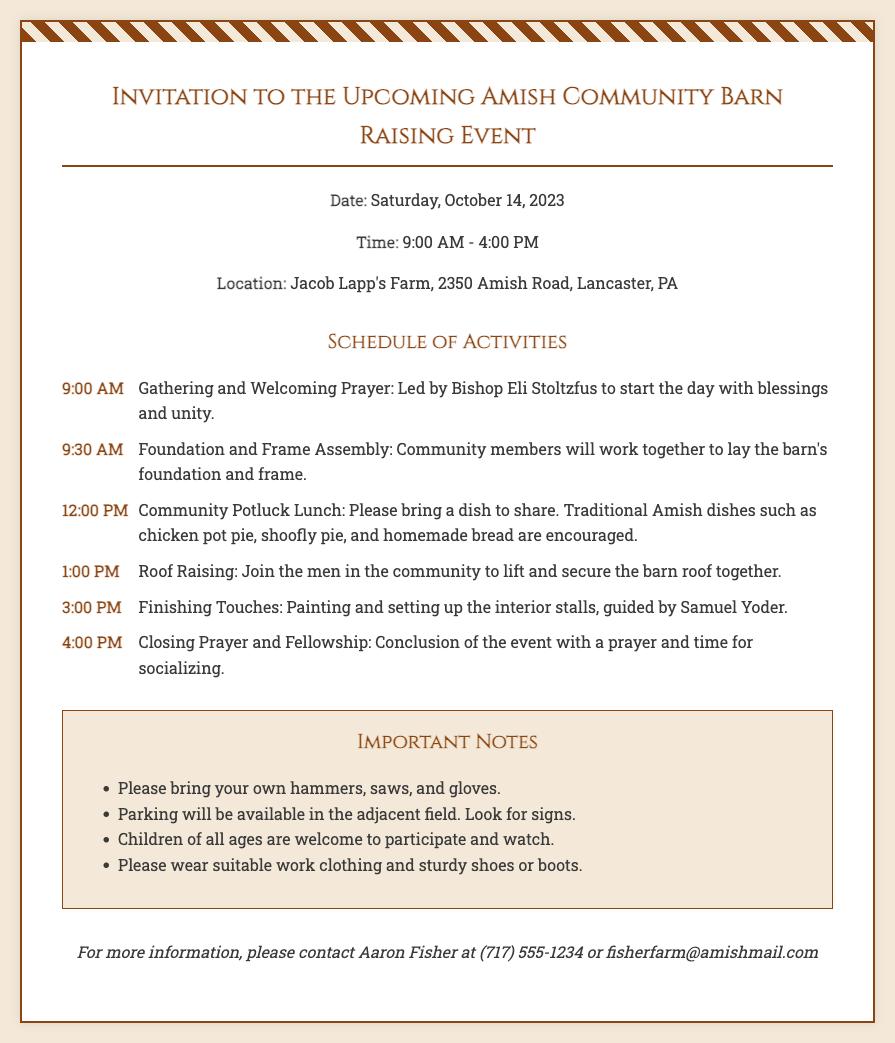What is the date of the barn raising event? The date of the barn raising event is specified in the document, which is Saturday, October 14, 2023.
Answer: Saturday, October 14, 2023 What time does the barn raising event start? The event start time is indicated in the document under the event details section.
Answer: 9:00 AM Where is the barn raising event taking place? The location is provided in the document, stating Jacob Lapp's Farm, along with the address.
Answer: Jacob Lapp's Farm, 2350 Amish Road, Lancaster, PA What is one of the traditional dishes encouraged for the potluck lunch? The document lists specific traditional Amish dishes for the potluck.
Answer: Chicken pot pie What activity occurs at 1:00 PM? The schedule of activities details the events and their respective times, including this one.
Answer: Roof Raising How many main activities are listed in the schedule? The number of activities can be counted from the schedule section of the document.
Answer: Five What should participants bring for the barn raising? Important notes mention bringing specific tools.
Answer: Hammers, saws, and gloves What is the purpose of the closing prayer at 4:00 PM? The schedule states that this prayer is part of the conclusion for the event for a specific reason.
Answer: To conclude the event and socialize Who should be contacted for more information? The contact information is provided at the end of the document for inquiries.
Answer: Aaron Fisher 